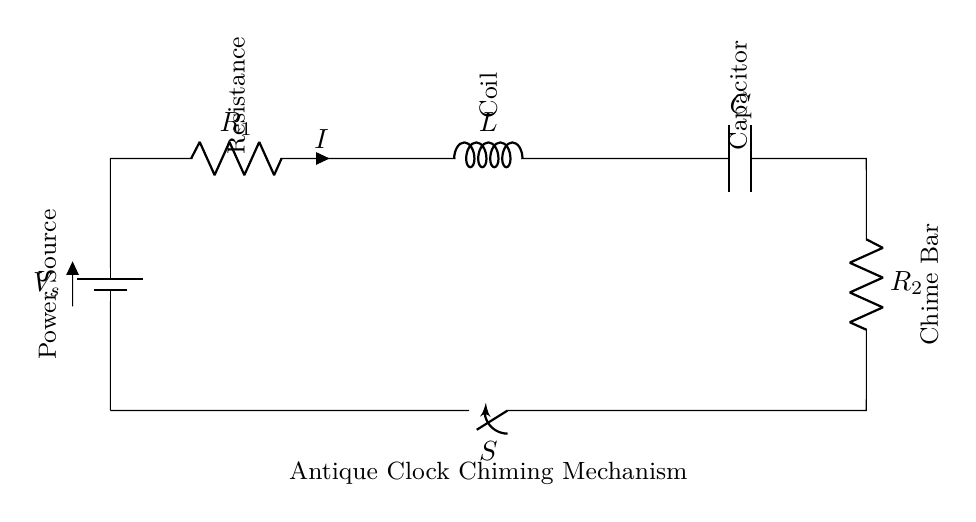What is the type of power source in this circuit? The circuit uses a battery as its power source, which is indicated by the label 'V_s' in the diagram.
Answer: battery What is the purpose of the coil in this antique clock? The coil (inductor) functions to create a magnetic field that helps in the mechanical movement of the chime bar when electric current flows through it.
Answer: magnetic movement What is the function of the capacitor in this circuit? The capacitor stores electrical energy temporarily and helps to smooth out fluctuations in the current, ensuring a steady flow to the chime mechanism.
Answer: energy storage What does the switch do in this circuit? The switch controls the flow of current within the circuit, allowing the user to turn the chime mechanism on or off as desired.
Answer: current control How many resistors are there in this circuit? There are two resistors (R_1 and R_2) present in the circuit diagram.
Answer: two What happens to the current when the switch is closed? When the switch is closed, it completes the circuit, allowing current to flow through the components and activate the chime mechanism.
Answer: current flows What is the significance of the chime bar in this circuit? The chime bar is the output component that produces melodic sounds as it resonates when struck, typically by a mechanical arm driven by the coil.
Answer: produces sound 